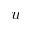<formula> <loc_0><loc_0><loc_500><loc_500>u</formula> 